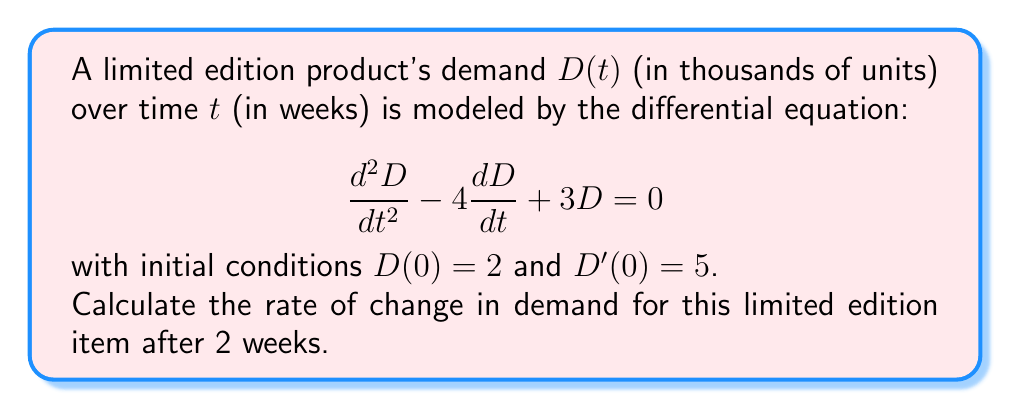Help me with this question. To solve this problem, we need to follow these steps:

1) First, we need to solve the characteristic equation to find the general solution:
   $$r^2 - 4r + 3 = 0$$
   $$(r - 3)(r - 1) = 0$$
   So, $r = 3$ or $r = 1$

2) The general solution is therefore:
   $$D(t) = c_1e^{3t} + c_2e^t$$

3) Now we use the initial conditions to find $c_1$ and $c_2$:
   For $D(0) = 2$:
   $$2 = c_1 + c_2$$

   For $D'(0) = 5$:
   $$D'(t) = 3c_1e^{3t} + c_2e^t$$
   $$5 = 3c_1 + c_2$$

4) Solving these equations:
   $$c_2 = 2 - c_1$$
   $$5 = 3c_1 + (2 - c_1)$$
   $$5 = 2c_1 + 2$$
   $$c_1 = \frac{3}{2}$$
   $$c_2 = \frac{1}{2}$$

5) So our particular solution is:
   $$D(t) = \frac{3}{2}e^{3t} + \frac{1}{2}e^t$$

6) To find the rate of change at $t = 2$, we need to differentiate $D(t)$:
   $$D'(t) = \frac{9}{2}e^{3t} + \frac{1}{2}e^t$$

7) Now we can evaluate $D'(2)$:
   $$D'(2) = \frac{9}{2}e^6 + \frac{1}{2}e^2$$

8) Calculate this value:
   $$D'(2) \approx 404.28 + 3.69 \approx 407.97$$
Answer: The rate of change in demand for the limited edition item after 2 weeks is approximately 407.97 thousand units per week. 